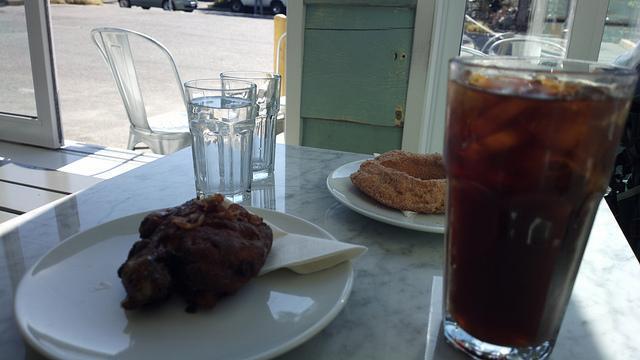Which object would have the least amount of flavors in it?
Make your selection from the four choices given to correctly answer the question.
Options: Donut, water glass, brown food, soda glass. Water glass. 